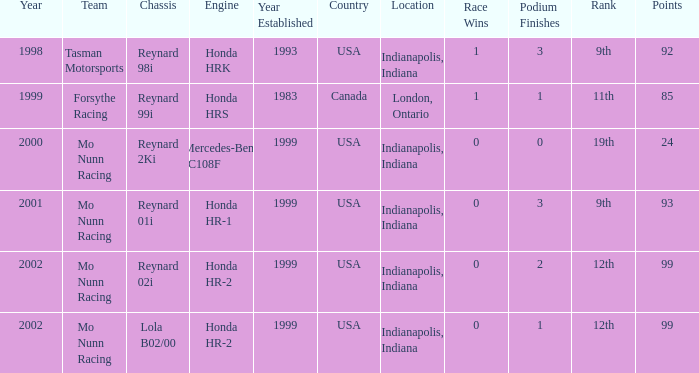What is the rank of the reynard 2ki chassis before 2002? 19th. 